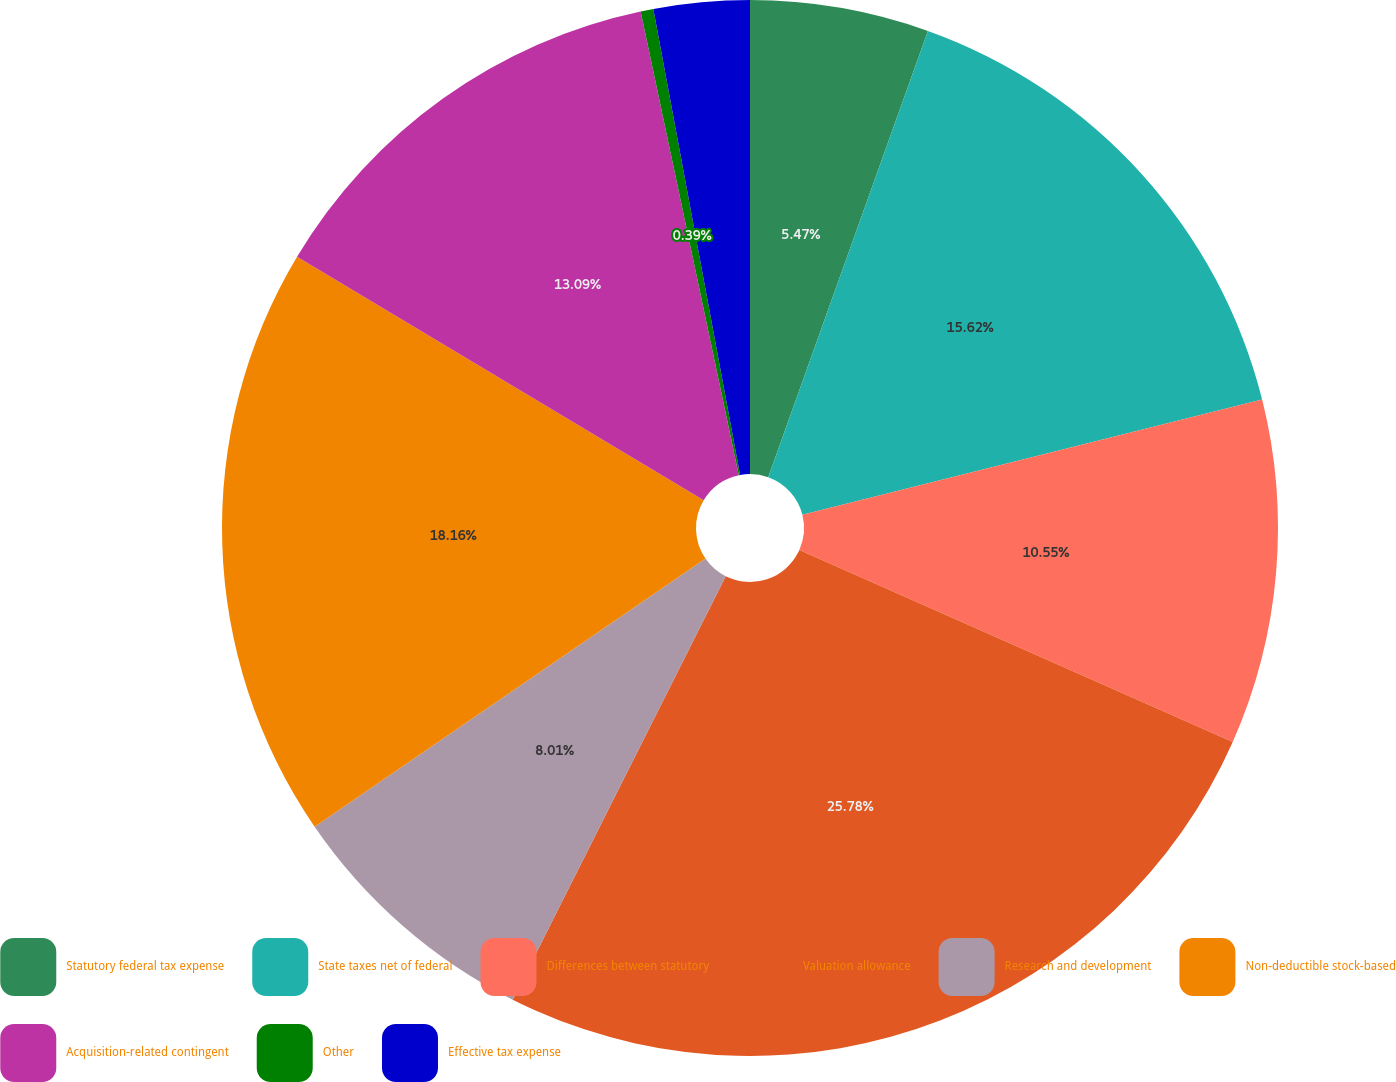Convert chart. <chart><loc_0><loc_0><loc_500><loc_500><pie_chart><fcel>Statutory federal tax expense<fcel>State taxes net of federal<fcel>Differences between statutory<fcel>Valuation allowance<fcel>Research and development<fcel>Non-deductible stock-based<fcel>Acquisition-related contingent<fcel>Other<fcel>Effective tax expense<nl><fcel>5.47%<fcel>15.62%<fcel>10.55%<fcel>25.78%<fcel>8.01%<fcel>18.16%<fcel>13.09%<fcel>0.39%<fcel>2.93%<nl></chart> 